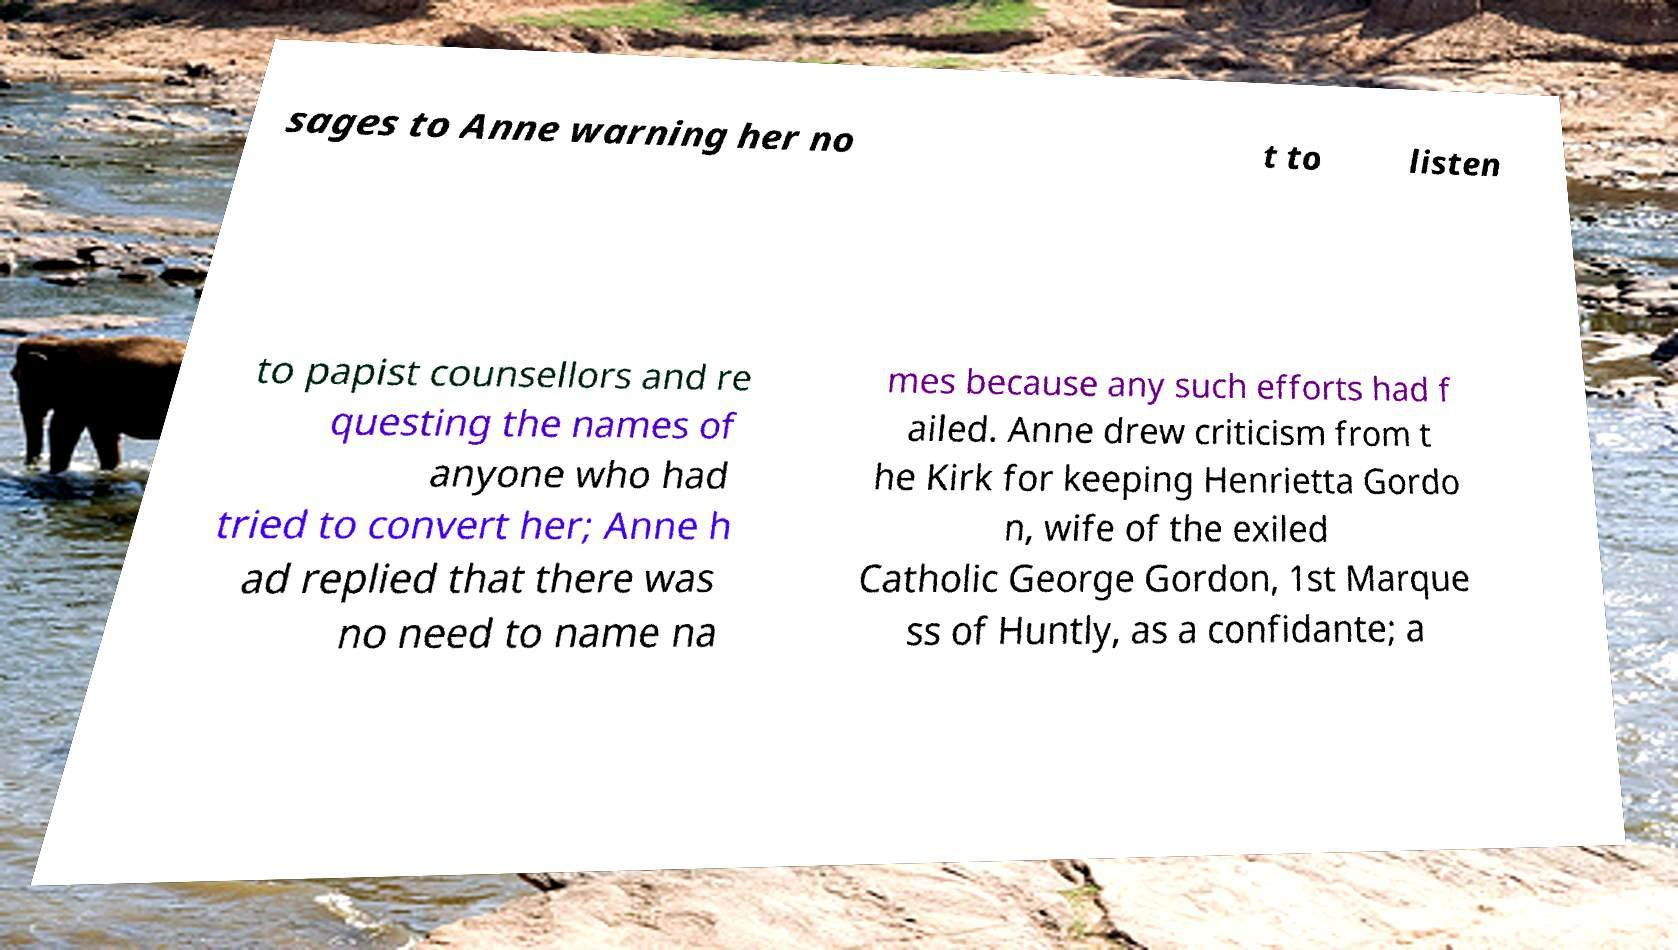Please read and relay the text visible in this image. What does it say? sages to Anne warning her no t to listen to papist counsellors and re questing the names of anyone who had tried to convert her; Anne h ad replied that there was no need to name na mes because any such efforts had f ailed. Anne drew criticism from t he Kirk for keeping Henrietta Gordo n, wife of the exiled Catholic George Gordon, 1st Marque ss of Huntly, as a confidante; a 